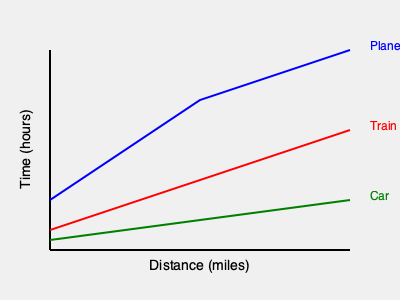Your partner is planning a business trip and needs to travel 300 miles. Based on the graph showing travel times for different modes of transportation, how much longer would it take to travel by car compared to flying? To solve this problem, we need to follow these steps:

1. Identify the travel time for each mode of transportation at 300 miles:
   - For the plane (blue line), at 300 miles, the time is approximately 2 hours.
   - For the car (green line), at 300 miles, the time is approximately 5 hours.

2. Calculate the difference in travel time:
   $$ \text{Time difference} = \text{Car time} - \text{Plane time} $$
   $$ \text{Time difference} = 5 \text{ hours} - 2 \text{ hours} = 3 \text{ hours} $$

Therefore, traveling by car would take approximately 3 hours longer than flying for a 300-mile trip.
Answer: 3 hours 